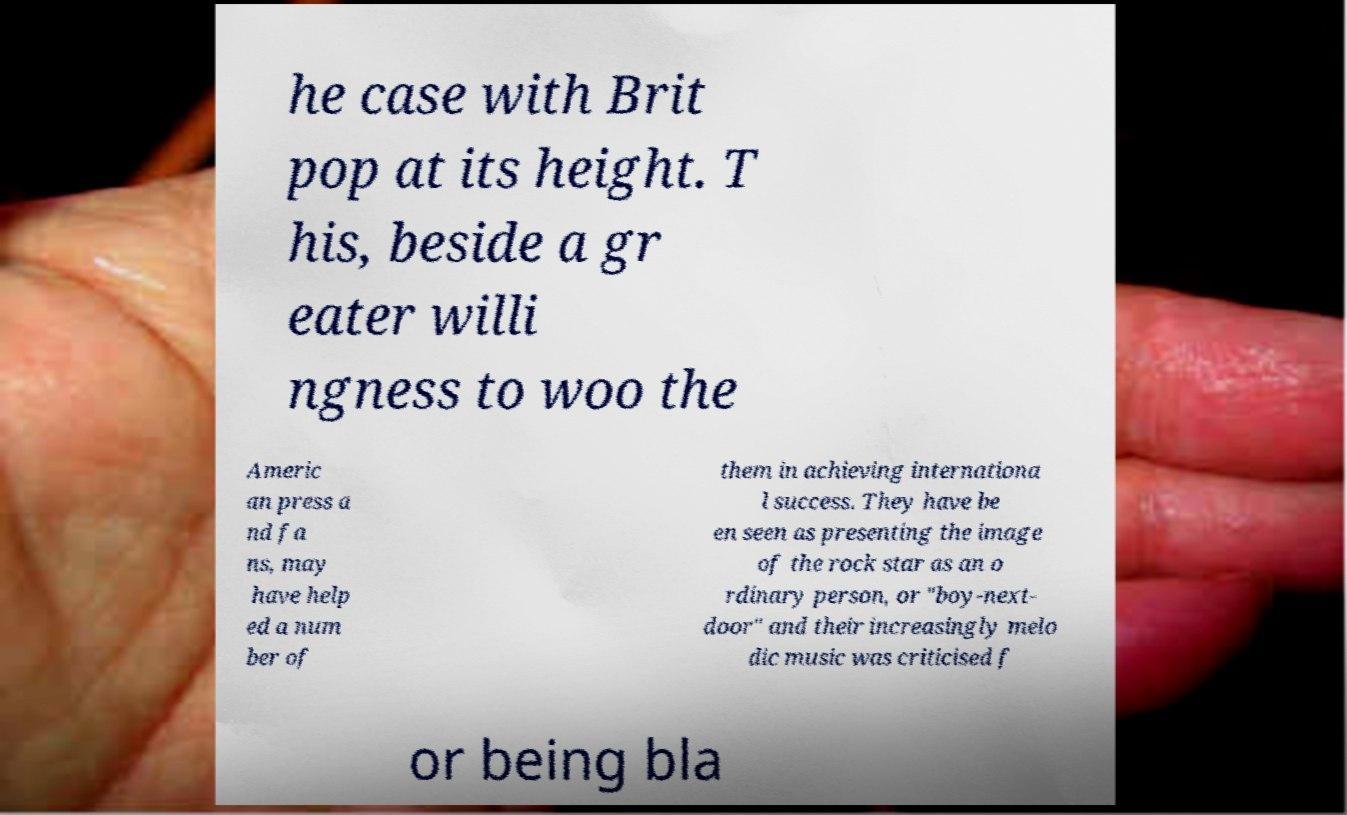Please read and relay the text visible in this image. What does it say? he case with Brit pop at its height. T his, beside a gr eater willi ngness to woo the Americ an press a nd fa ns, may have help ed a num ber of them in achieving internationa l success. They have be en seen as presenting the image of the rock star as an o rdinary person, or "boy-next- door" and their increasingly melo dic music was criticised f or being bla 